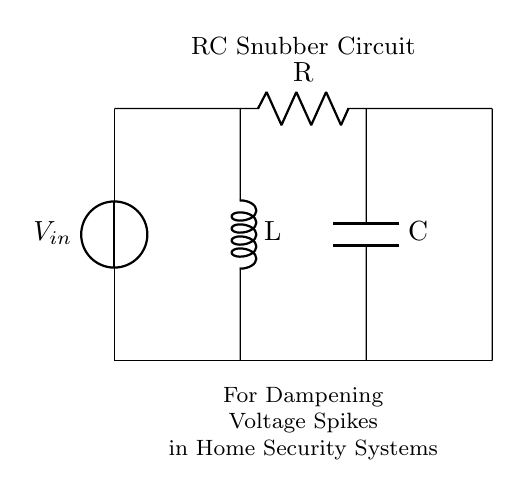What components are in this circuit? The components are a voltage source, resistor, capacitor, and inductor. These are the basic building blocks represented in the circuit diagram.
Answer: voltage source, resistor, capacitor, inductor What does the snubber circuit do? The snubber circuit dampens voltage spikes, which helps protect sensitive components in the circuit from potential damage caused by these spikes.
Answer: dampens voltage spikes What is the function of the resistor in this circuit? The resistor limits the current flowing through the circuit and can help in dissipating energy, which is key for managing voltage spikes effectively.
Answer: limits current How are the capacitor and inductor positioned in the circuit? The capacitor is connected vertically in parallel with the load, and the inductor is connected vertically in series; this arrangement plays a crucial role in filtering transients effectively.
Answer: capacitor parallel, inductor series What is the role of the voltage source? The voltage source provides the necessary electrical potential for the circuit operation, delivering the current needed to manage components' function and react to voltage spikes.
Answer: provides potential How does the RLC combination affect the signal? The resistor, inductor, and capacitor work together to create an RC time constant that influences how quickly the circuit can respond to voltage changes, affecting signal integrity.
Answer: affects signal integrity What type of circuit is this? This is an RC snubber circuit, specifically designed for applications such as dampening voltage spikes in home security systems.
Answer: RC snubber circuit 